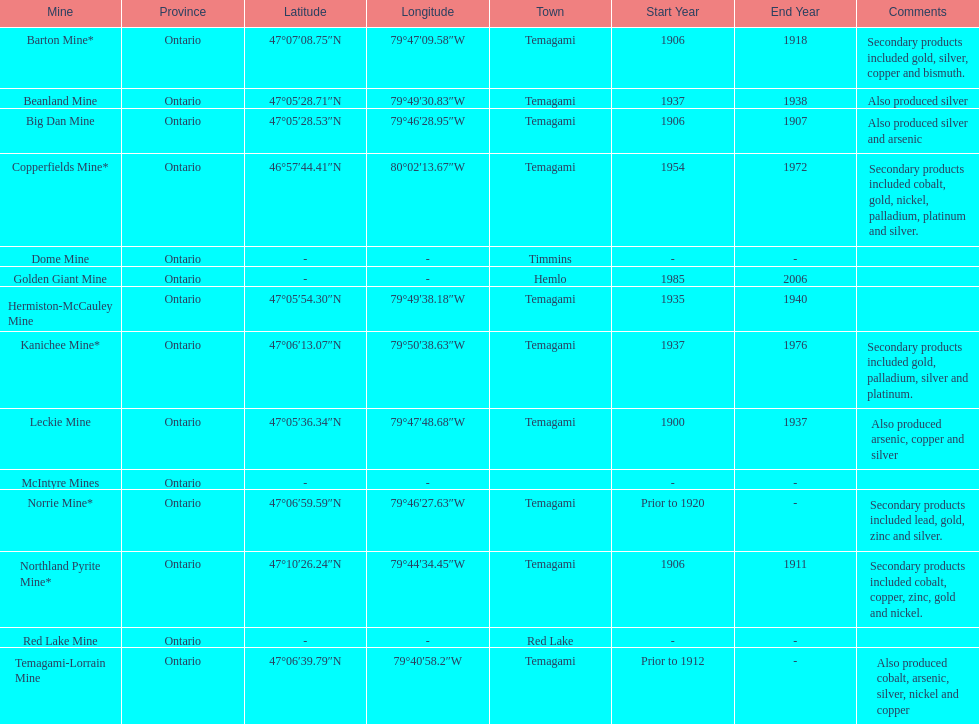What province is the town of temagami? Ontario. 